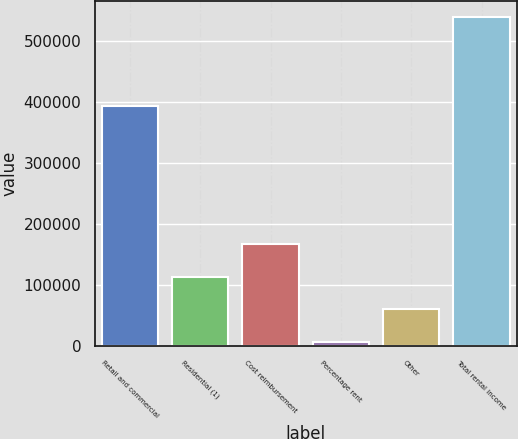Convert chart. <chart><loc_0><loc_0><loc_500><loc_500><bar_chart><fcel>Retail and commercial<fcel>Residential (1)<fcel>Cost reimbursement<fcel>Percentage rent<fcel>Other<fcel>Total rental income<nl><fcel>392657<fcel>113801<fcel>166914<fcel>7576<fcel>60688.5<fcel>538701<nl></chart> 